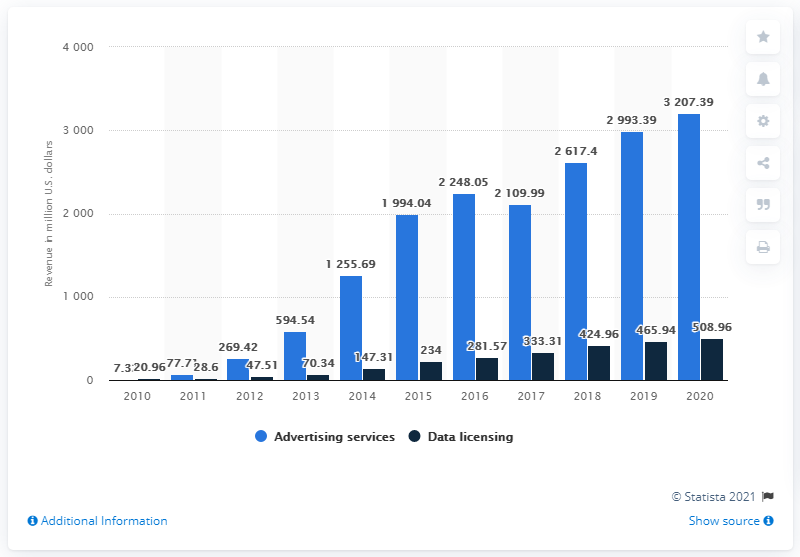How much advertising revenue did Twitter generate in the most recent fiscal period?
 3207.39 